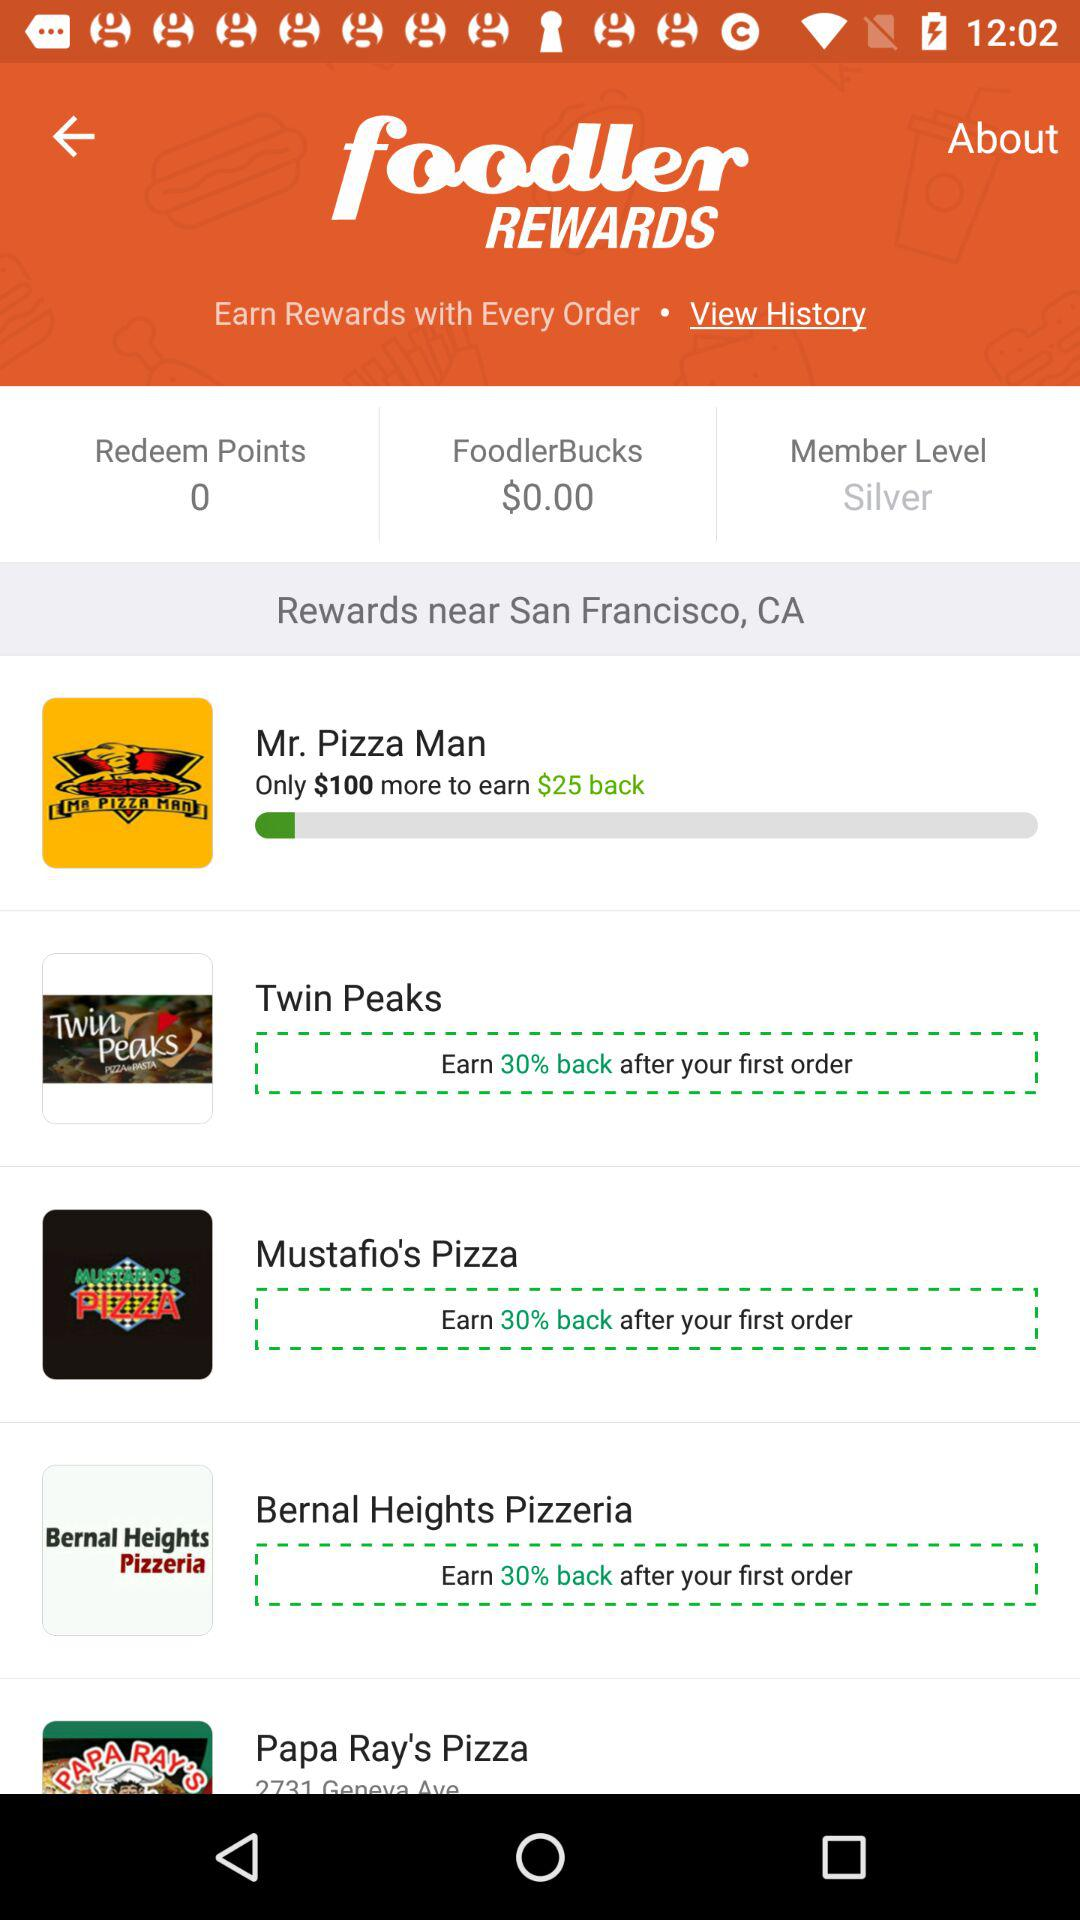What is the reward percentage on the first order of "Mustafio's Pizza"? The reward percentage on the first order of "Mustafio's Pizza" is 30. 